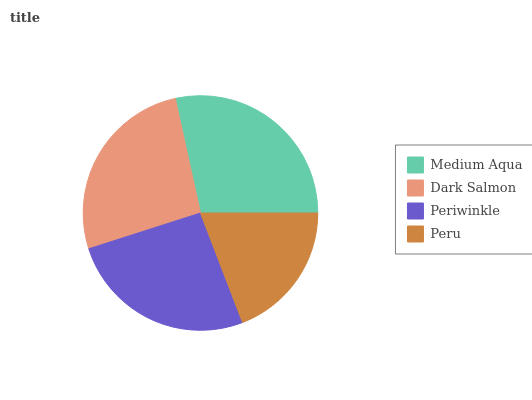Is Peru the minimum?
Answer yes or no. Yes. Is Medium Aqua the maximum?
Answer yes or no. Yes. Is Dark Salmon the minimum?
Answer yes or no. No. Is Dark Salmon the maximum?
Answer yes or no. No. Is Medium Aqua greater than Dark Salmon?
Answer yes or no. Yes. Is Dark Salmon less than Medium Aqua?
Answer yes or no. Yes. Is Dark Salmon greater than Medium Aqua?
Answer yes or no. No. Is Medium Aqua less than Dark Salmon?
Answer yes or no. No. Is Dark Salmon the high median?
Answer yes or no. Yes. Is Periwinkle the low median?
Answer yes or no. Yes. Is Medium Aqua the high median?
Answer yes or no. No. Is Medium Aqua the low median?
Answer yes or no. No. 